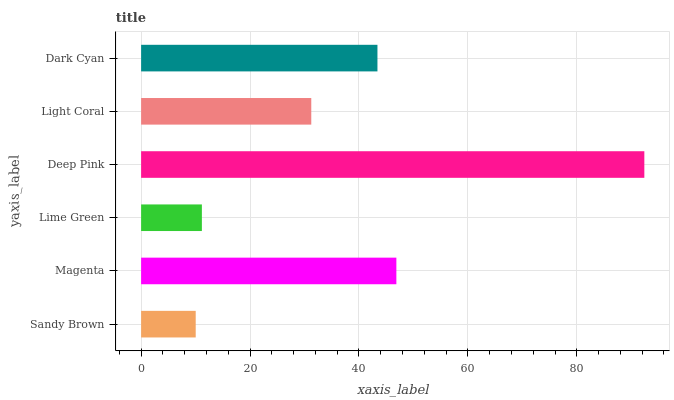Is Sandy Brown the minimum?
Answer yes or no. Yes. Is Deep Pink the maximum?
Answer yes or no. Yes. Is Magenta the minimum?
Answer yes or no. No. Is Magenta the maximum?
Answer yes or no. No. Is Magenta greater than Sandy Brown?
Answer yes or no. Yes. Is Sandy Brown less than Magenta?
Answer yes or no. Yes. Is Sandy Brown greater than Magenta?
Answer yes or no. No. Is Magenta less than Sandy Brown?
Answer yes or no. No. Is Dark Cyan the high median?
Answer yes or no. Yes. Is Light Coral the low median?
Answer yes or no. Yes. Is Sandy Brown the high median?
Answer yes or no. No. Is Sandy Brown the low median?
Answer yes or no. No. 